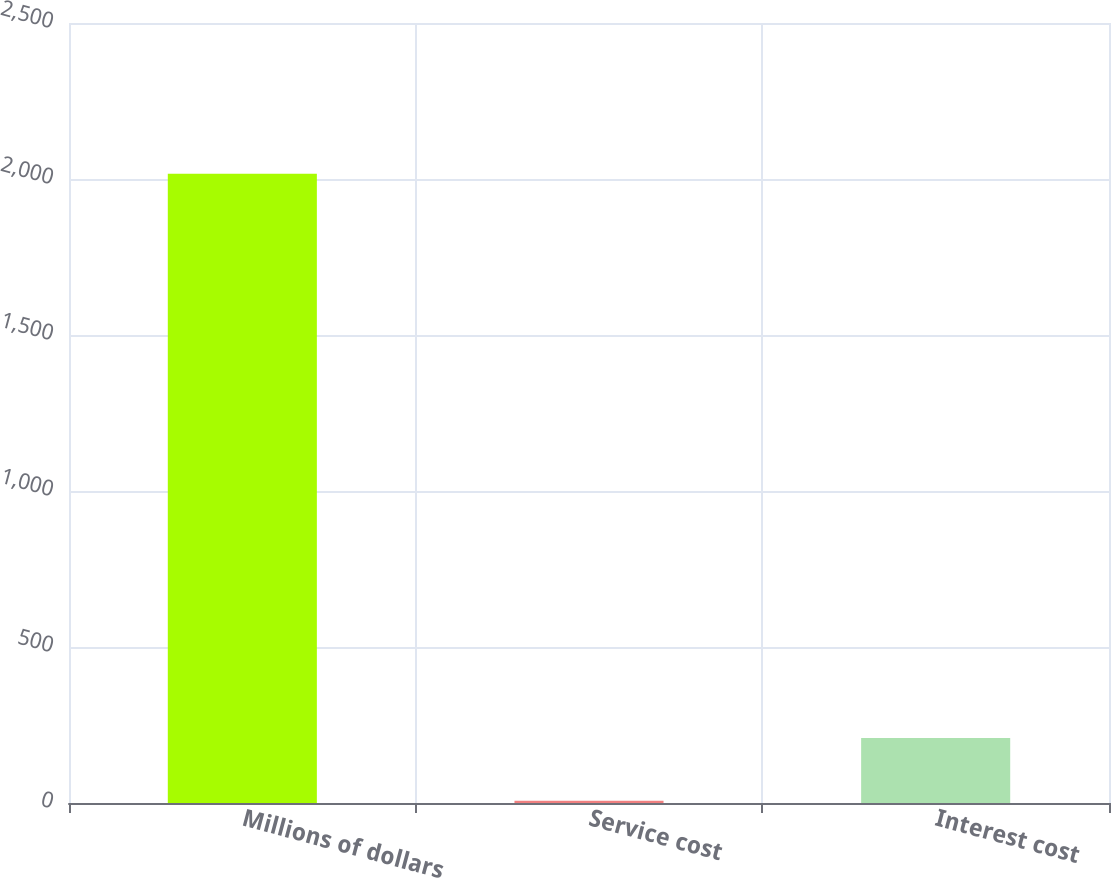Convert chart. <chart><loc_0><loc_0><loc_500><loc_500><bar_chart><fcel>Millions of dollars<fcel>Service cost<fcel>Interest cost<nl><fcel>2017<fcel>7<fcel>208<nl></chart> 